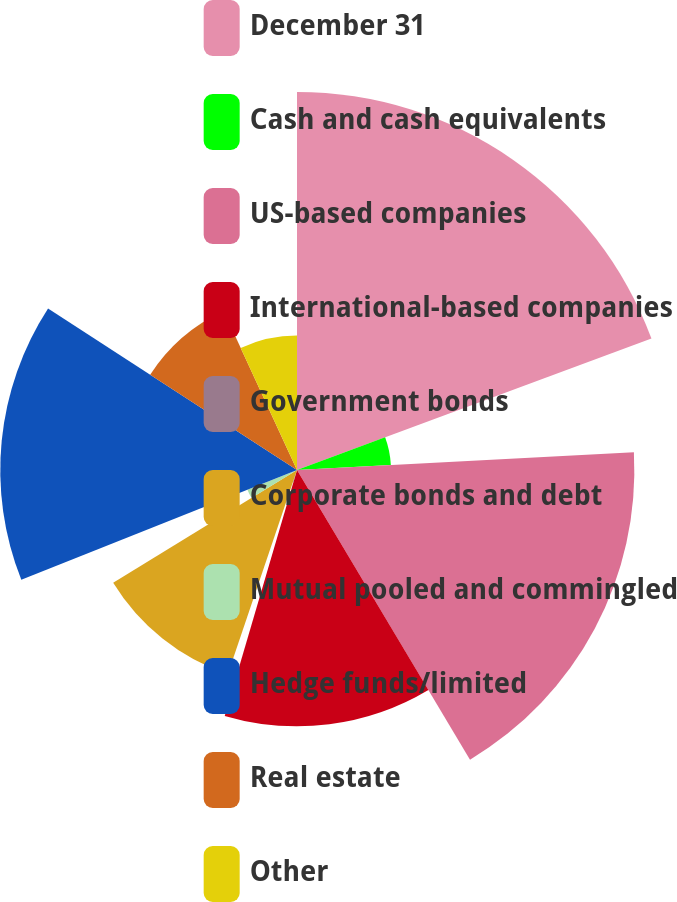Convert chart. <chart><loc_0><loc_0><loc_500><loc_500><pie_chart><fcel>December 31<fcel>Cash and cash equivalents<fcel>US-based companies<fcel>International-based companies<fcel>Government bonds<fcel>Corporate bonds and debt<fcel>Mutual pooled and commingled<fcel>Hedge funds/limited<fcel>Real estate<fcel>Other<nl><fcel>19.35%<fcel>4.81%<fcel>17.27%<fcel>13.12%<fcel>0.65%<fcel>11.04%<fcel>2.73%<fcel>15.19%<fcel>8.96%<fcel>6.88%<nl></chart> 